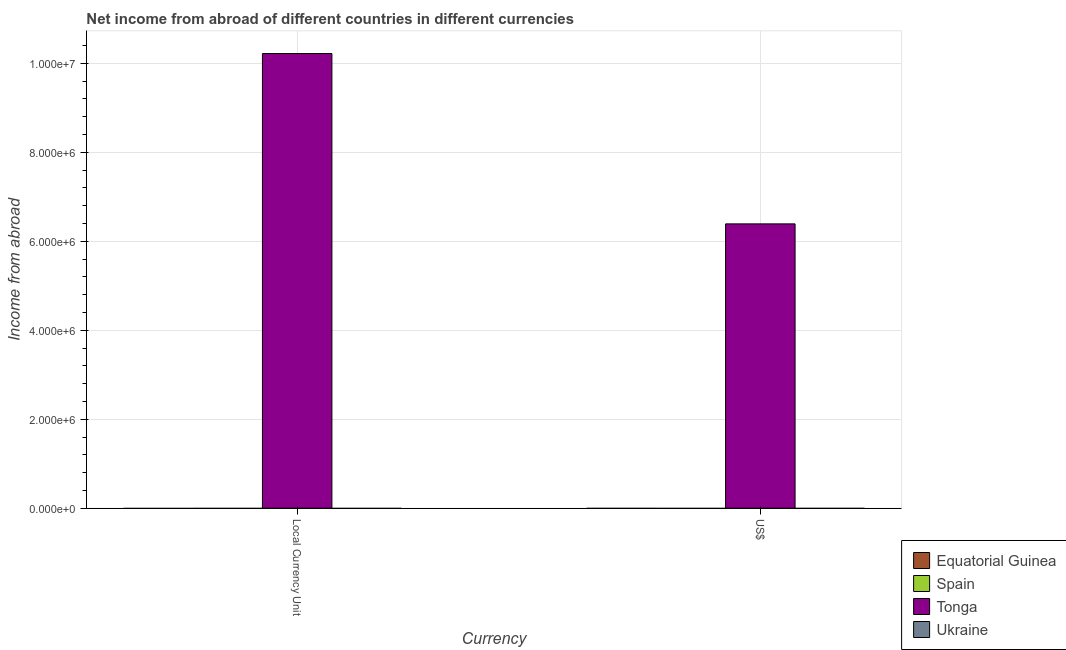Are the number of bars on each tick of the X-axis equal?
Your answer should be compact. Yes. How many bars are there on the 2nd tick from the right?
Offer a terse response. 1. What is the label of the 1st group of bars from the left?
Offer a terse response. Local Currency Unit. What is the income from abroad in constant 2005 us$ in Ukraine?
Give a very brief answer. 0. Across all countries, what is the maximum income from abroad in constant 2005 us$?
Your response must be concise. 1.02e+07. In which country was the income from abroad in us$ maximum?
Offer a very short reply. Tonga. What is the total income from abroad in constant 2005 us$ in the graph?
Offer a terse response. 1.02e+07. What is the average income from abroad in us$ per country?
Your response must be concise. 1.60e+06. What is the difference between the income from abroad in constant 2005 us$ and income from abroad in us$ in Tonga?
Give a very brief answer. 3.83e+06. How many countries are there in the graph?
Ensure brevity in your answer.  4. Are the values on the major ticks of Y-axis written in scientific E-notation?
Make the answer very short. Yes. Does the graph contain grids?
Make the answer very short. Yes. Where does the legend appear in the graph?
Make the answer very short. Bottom right. How many legend labels are there?
Provide a short and direct response. 4. What is the title of the graph?
Keep it short and to the point. Net income from abroad of different countries in different currencies. What is the label or title of the X-axis?
Offer a terse response. Currency. What is the label or title of the Y-axis?
Your answer should be very brief. Income from abroad. What is the Income from abroad of Tonga in Local Currency Unit?
Your answer should be very brief. 1.02e+07. What is the Income from abroad of Ukraine in Local Currency Unit?
Your answer should be compact. 0. What is the Income from abroad in Equatorial Guinea in US$?
Make the answer very short. 0. What is the Income from abroad of Tonga in US$?
Offer a terse response. 6.39e+06. Across all Currency, what is the maximum Income from abroad of Tonga?
Provide a short and direct response. 1.02e+07. Across all Currency, what is the minimum Income from abroad of Tonga?
Offer a terse response. 6.39e+06. What is the total Income from abroad in Tonga in the graph?
Your answer should be compact. 1.66e+07. What is the difference between the Income from abroad in Tonga in Local Currency Unit and that in US$?
Give a very brief answer. 3.83e+06. What is the average Income from abroad in Tonga per Currency?
Give a very brief answer. 8.30e+06. What is the ratio of the Income from abroad in Tonga in Local Currency Unit to that in US$?
Provide a short and direct response. 1.6. What is the difference between the highest and the second highest Income from abroad of Tonga?
Give a very brief answer. 3.83e+06. What is the difference between the highest and the lowest Income from abroad of Tonga?
Ensure brevity in your answer.  3.83e+06. 